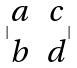<formula> <loc_0><loc_0><loc_500><loc_500>| \begin{matrix} a & c \\ b & d \end{matrix} |</formula> 